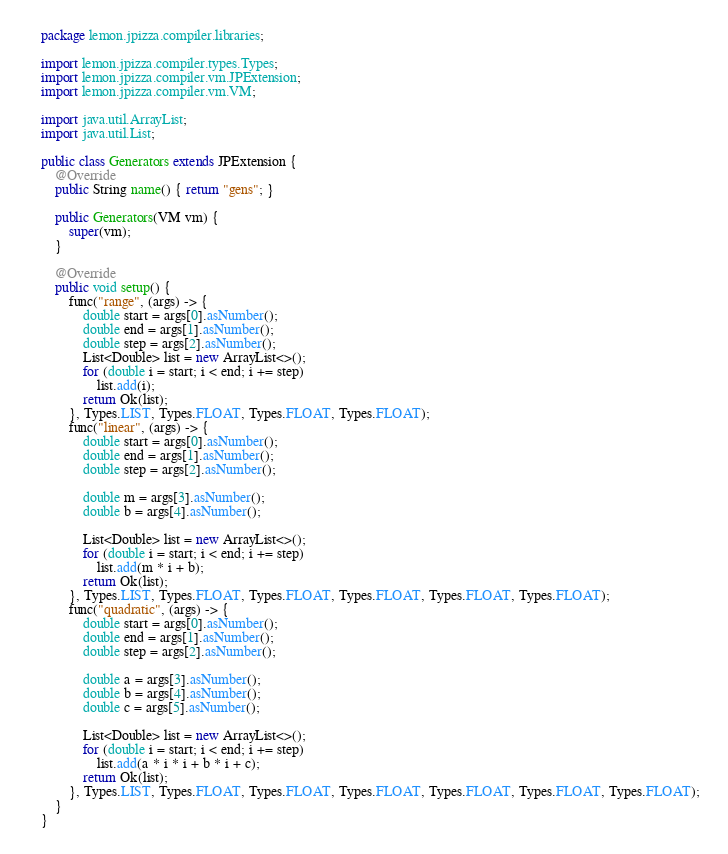Convert code to text. <code><loc_0><loc_0><loc_500><loc_500><_Java_>package lemon.jpizza.compiler.libraries;

import lemon.jpizza.compiler.types.Types;
import lemon.jpizza.compiler.vm.JPExtension;
import lemon.jpizza.compiler.vm.VM;

import java.util.ArrayList;
import java.util.List;

public class Generators extends JPExtension {
    @Override
    public String name() { return "gens"; }

    public Generators(VM vm) {
        super(vm);
    }

    @Override
    public void setup() {
        func("range", (args) -> {
            double start = args[0].asNumber();
            double end = args[1].asNumber();
            double step = args[2].asNumber();
            List<Double> list = new ArrayList<>();
            for (double i = start; i < end; i += step)
                list.add(i);
            return Ok(list);
        }, Types.LIST, Types.FLOAT, Types.FLOAT, Types.FLOAT);
        func("linear", (args) -> {
            double start = args[0].asNumber();
            double end = args[1].asNumber();
            double step = args[2].asNumber();

            double m = args[3].asNumber();
            double b = args[4].asNumber();

            List<Double> list = new ArrayList<>();
            for (double i = start; i < end; i += step)
                list.add(m * i + b);
            return Ok(list);
        }, Types.LIST, Types.FLOAT, Types.FLOAT, Types.FLOAT, Types.FLOAT, Types.FLOAT);
        func("quadratic", (args) -> {
            double start = args[0].asNumber();
            double end = args[1].asNumber();
            double step = args[2].asNumber();

            double a = args[3].asNumber();
            double b = args[4].asNumber();
            double c = args[5].asNumber();

            List<Double> list = new ArrayList<>();
            for (double i = start; i < end; i += step)
                list.add(a * i * i + b * i + c);
            return Ok(list);
        }, Types.LIST, Types.FLOAT, Types.FLOAT, Types.FLOAT, Types.FLOAT, Types.FLOAT, Types.FLOAT);
    }
}
</code> 